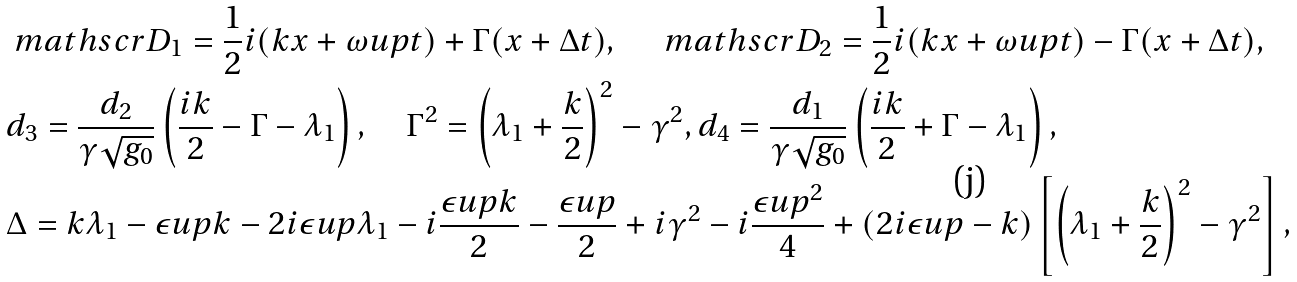<formula> <loc_0><loc_0><loc_500><loc_500>& \ m a t h s c r { D } _ { 1 } = \frac { 1 } { 2 } i ( k x + \omega u p t ) + \Gamma ( x + \Delta t ) , \quad \ m a t h s c r { D } _ { 2 } = \frac { 1 } { 2 } i ( k x + \omega u p t ) - \Gamma ( x + \Delta t ) , \\ & d _ { 3 } = \frac { d _ { 2 } } { \gamma \sqrt { g _ { 0 } } } \left ( \frac { i k } { 2 } - \Gamma - \lambda _ { 1 } \right ) , \quad \Gamma ^ { 2 } = \left ( \lambda _ { 1 } + \frac { k } { 2 } \right ) ^ { 2 } - \gamma ^ { 2 } , d _ { 4 } = \frac { d _ { 1 } } { \gamma \sqrt { g _ { 0 } } } \left ( \frac { i k } { 2 } + \Gamma - \lambda _ { 1 } \right ) , \\ & \Delta = k \lambda _ { 1 } - \epsilon u p k - 2 i \epsilon u p \lambda _ { 1 } - i \frac { \epsilon u p k } { 2 } - \frac { \epsilon u p } { 2 } + i \gamma ^ { 2 } - i \frac { \epsilon u p ^ { 2 } } { 4 } + ( 2 i \epsilon u p - k ) \left [ \left ( \lambda _ { 1 } + \frac { k } { 2 } \right ) ^ { 2 } - \gamma ^ { 2 } \right ] ,</formula> 